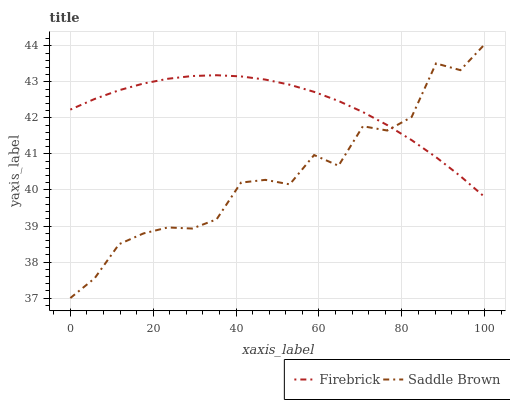Does Saddle Brown have the maximum area under the curve?
Answer yes or no. No. Is Saddle Brown the smoothest?
Answer yes or no. No. 